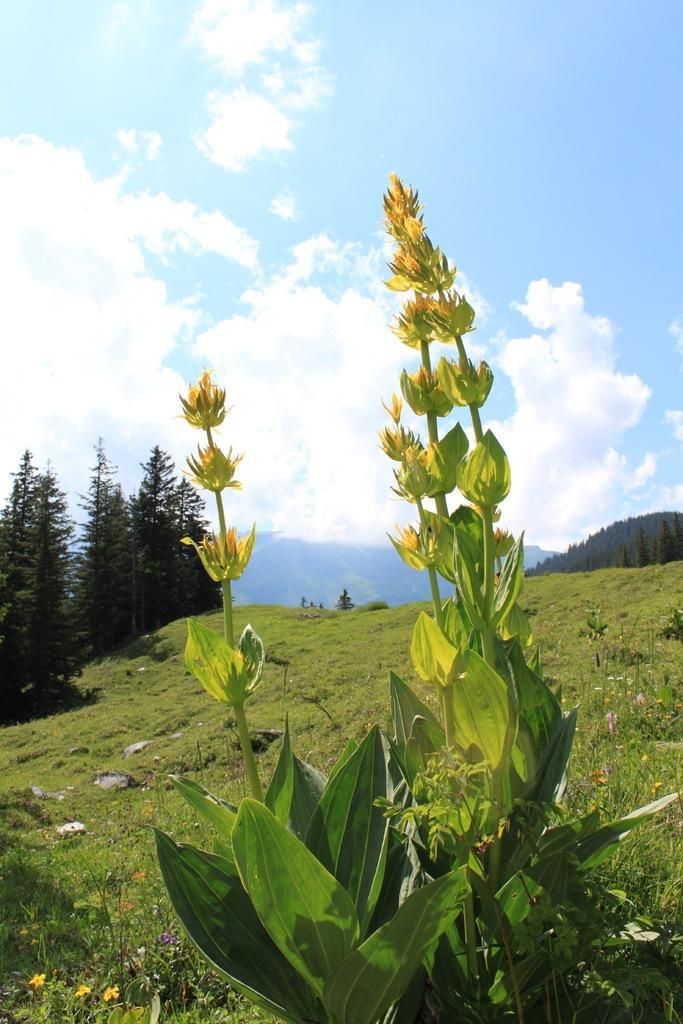Describe this image in one or two sentences. In the image I can see plants, the grass and trees. In the background I can see hills and the sky. 